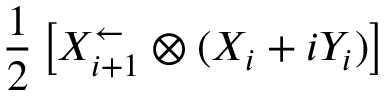<formula> <loc_0><loc_0><loc_500><loc_500>\frac { 1 } { 2 } \left [ X _ { i + 1 } ^ { \leftarrow } \otimes ( X _ { i } + i Y _ { i } ) \right ]</formula> 